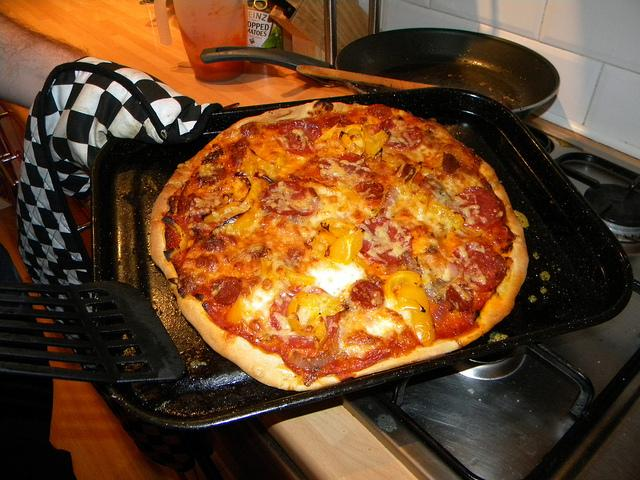The pizza came out of the oven powered by which fuel source?

Choices:
A) propane
B) charcoal
C) electricity
D) natural gas natural gas 